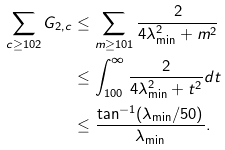Convert formula to latex. <formula><loc_0><loc_0><loc_500><loc_500>\sum _ { c \geq 1 0 2 } G _ { 2 , c } & \leq \sum _ { m \geq 1 0 1 } \frac { 2 } { 4 \lambda _ { \min } ^ { 2 } + m ^ { 2 } } \\ & \leq \int _ { 1 0 0 } ^ { \infty } \frac { 2 } { 4 \lambda _ { \min } ^ { 2 } + t ^ { 2 } } d t \\ & \leq \frac { \tan ^ { - 1 } ( \lambda _ { \min } / 5 0 ) } { \lambda _ { \min } } .</formula> 